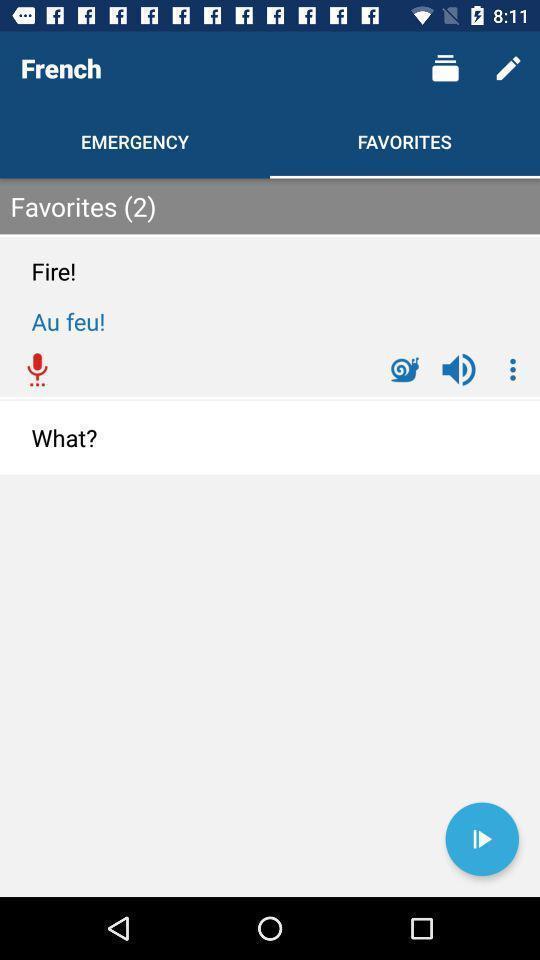Summarize the main components in this picture. Page showing language learning application. 